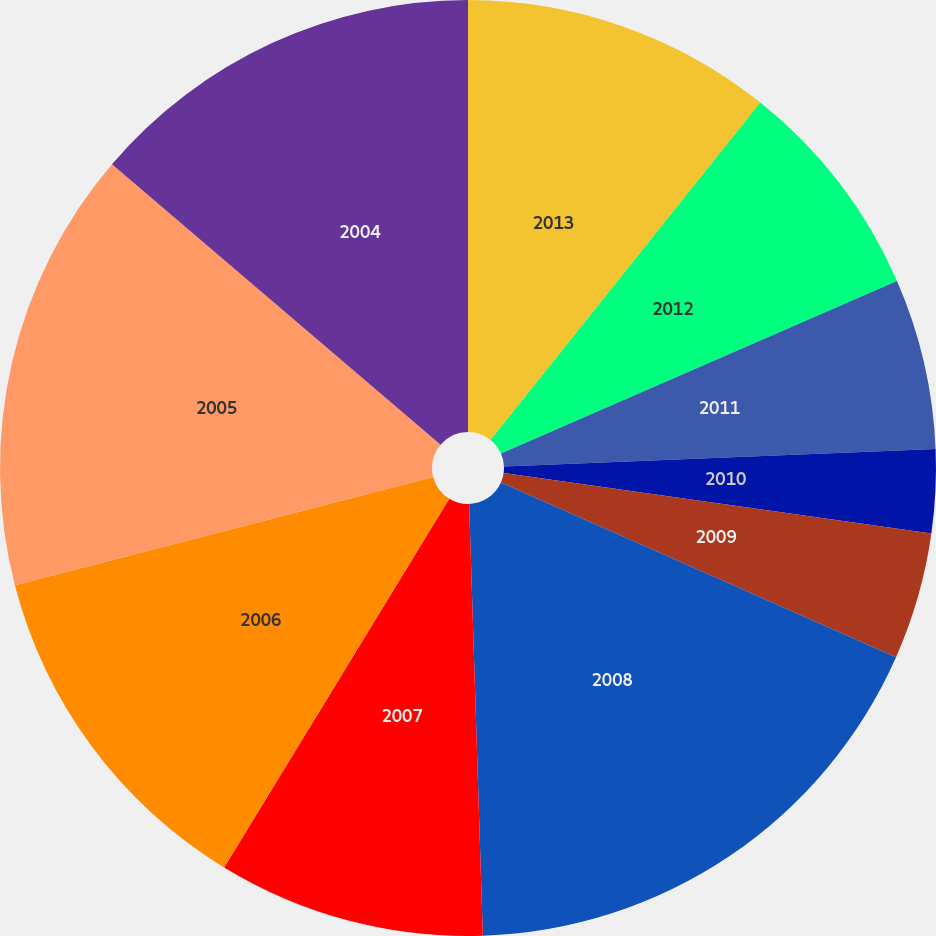<chart> <loc_0><loc_0><loc_500><loc_500><pie_chart><fcel>2013<fcel>2012<fcel>2011<fcel>2010<fcel>2009<fcel>2008<fcel>2007<fcel>2006<fcel>2005<fcel>2004<nl><fcel>10.74%<fcel>7.72%<fcel>5.9%<fcel>2.88%<fcel>4.39%<fcel>17.87%<fcel>9.23%<fcel>12.25%<fcel>15.27%<fcel>13.76%<nl></chart> 